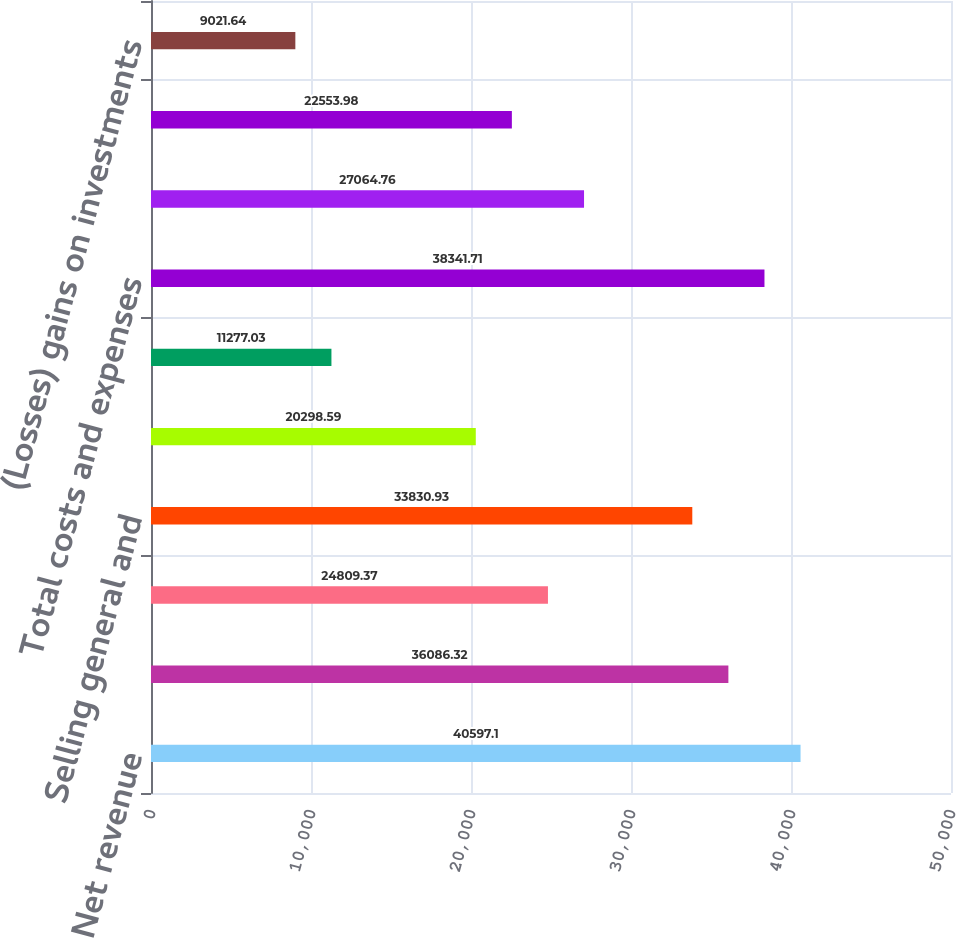Convert chart to OTSL. <chart><loc_0><loc_0><loc_500><loc_500><bar_chart><fcel>Net revenue<fcel>Cost of sales (1)<fcel>Research and development<fcel>Selling general and<fcel>Amortization of purchased<fcel>Restructuring<fcel>Total costs and expenses<fcel>Earnings from operations<fcel>Interest and other net<fcel>(Losses) gains on investments<nl><fcel>40597.1<fcel>36086.3<fcel>24809.4<fcel>33830.9<fcel>20298.6<fcel>11277<fcel>38341.7<fcel>27064.8<fcel>22554<fcel>9021.64<nl></chart> 